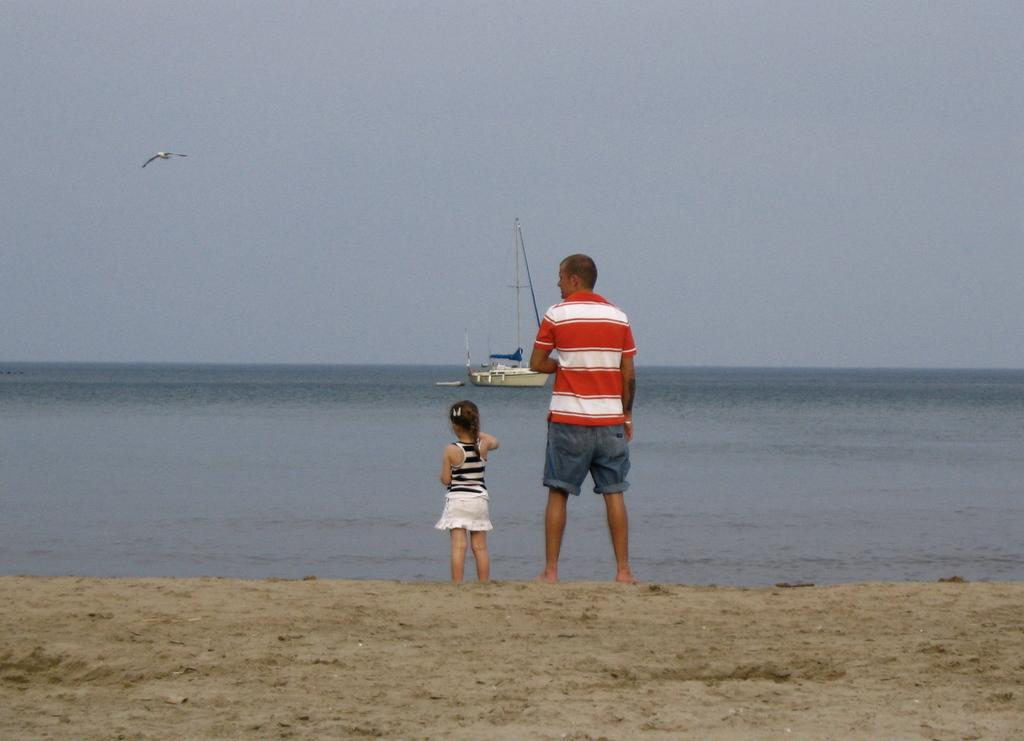What is present in the image that is not solid? There is water in the image. What type of animal can be seen in the image? There is a bird in the image. What part of the natural environment is visible in the image? The sky is visible in the image. What type of vehicle is in the image? There is a boat in the image. How many people are present in the image? Two people are standing in the image. What type of meat is being grilled by the people in the image? There is no meat or grill present in the image; it features water, a bird, the sky, a boat, and two people standing. 